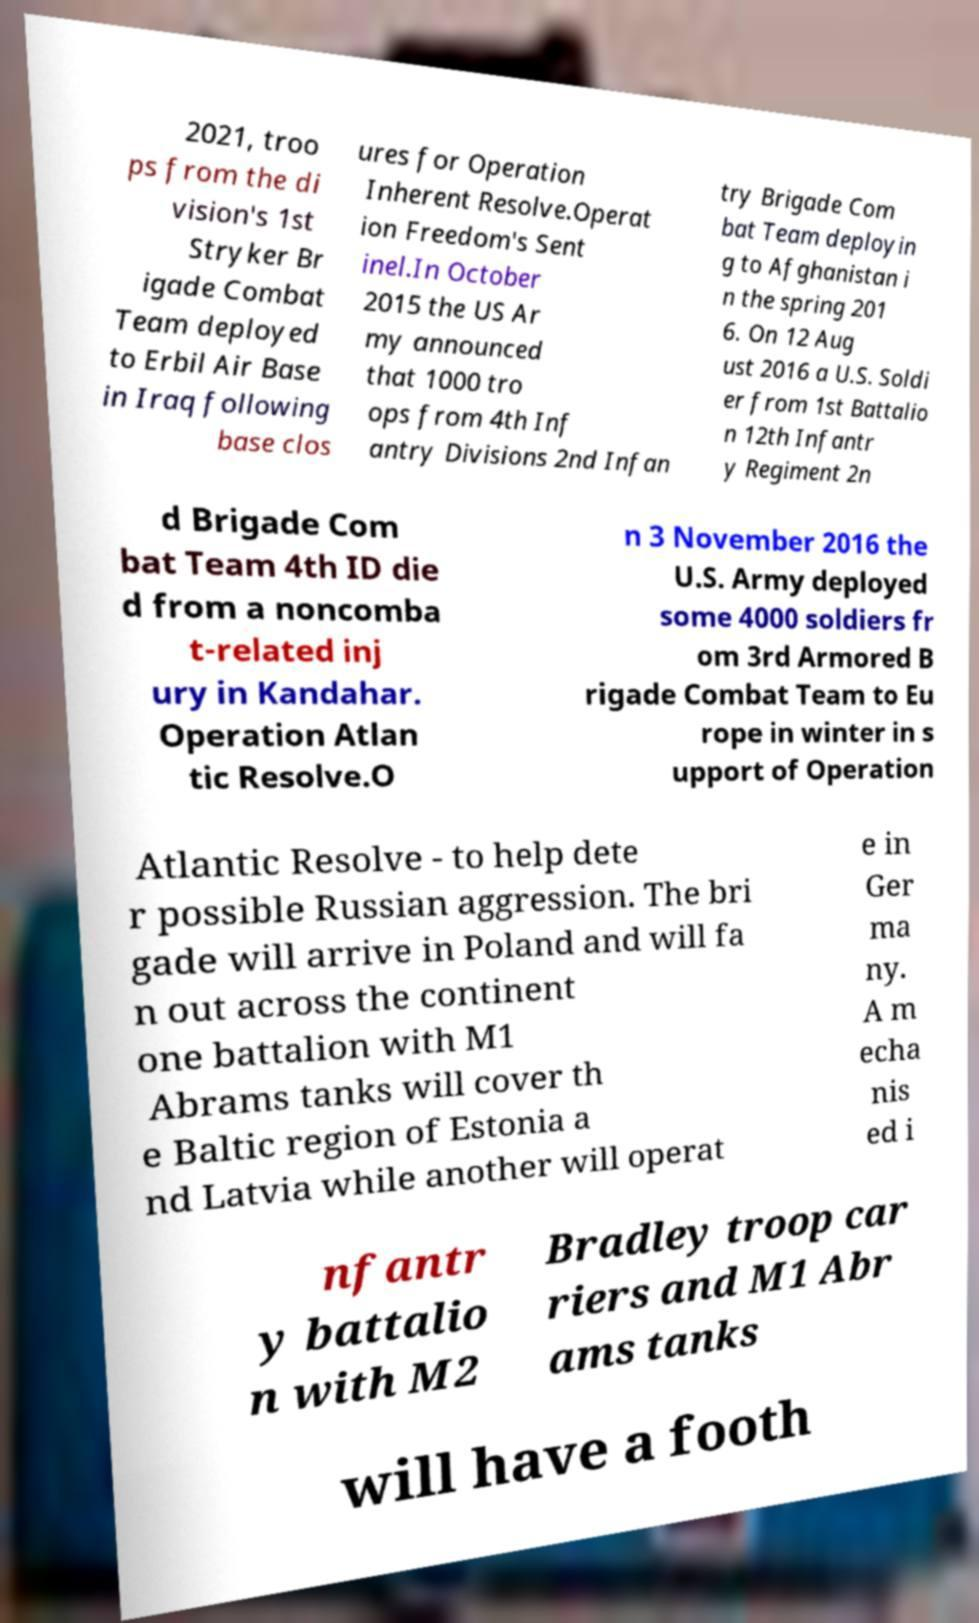I need the written content from this picture converted into text. Can you do that? 2021, troo ps from the di vision's 1st Stryker Br igade Combat Team deployed to Erbil Air Base in Iraq following base clos ures for Operation Inherent Resolve.Operat ion Freedom's Sent inel.In October 2015 the US Ar my announced that 1000 tro ops from 4th Inf antry Divisions 2nd Infan try Brigade Com bat Team deployin g to Afghanistan i n the spring 201 6. On 12 Aug ust 2016 a U.S. Soldi er from 1st Battalio n 12th Infantr y Regiment 2n d Brigade Com bat Team 4th ID die d from a noncomba t-related inj ury in Kandahar. Operation Atlan tic Resolve.O n 3 November 2016 the U.S. Army deployed some 4000 soldiers fr om 3rd Armored B rigade Combat Team to Eu rope in winter in s upport of Operation Atlantic Resolve - to help dete r possible Russian aggression. The bri gade will arrive in Poland and will fa n out across the continent one battalion with M1 Abrams tanks will cover th e Baltic region of Estonia a nd Latvia while another will operat e in Ger ma ny. A m echa nis ed i nfantr y battalio n with M2 Bradley troop car riers and M1 Abr ams tanks will have a footh 